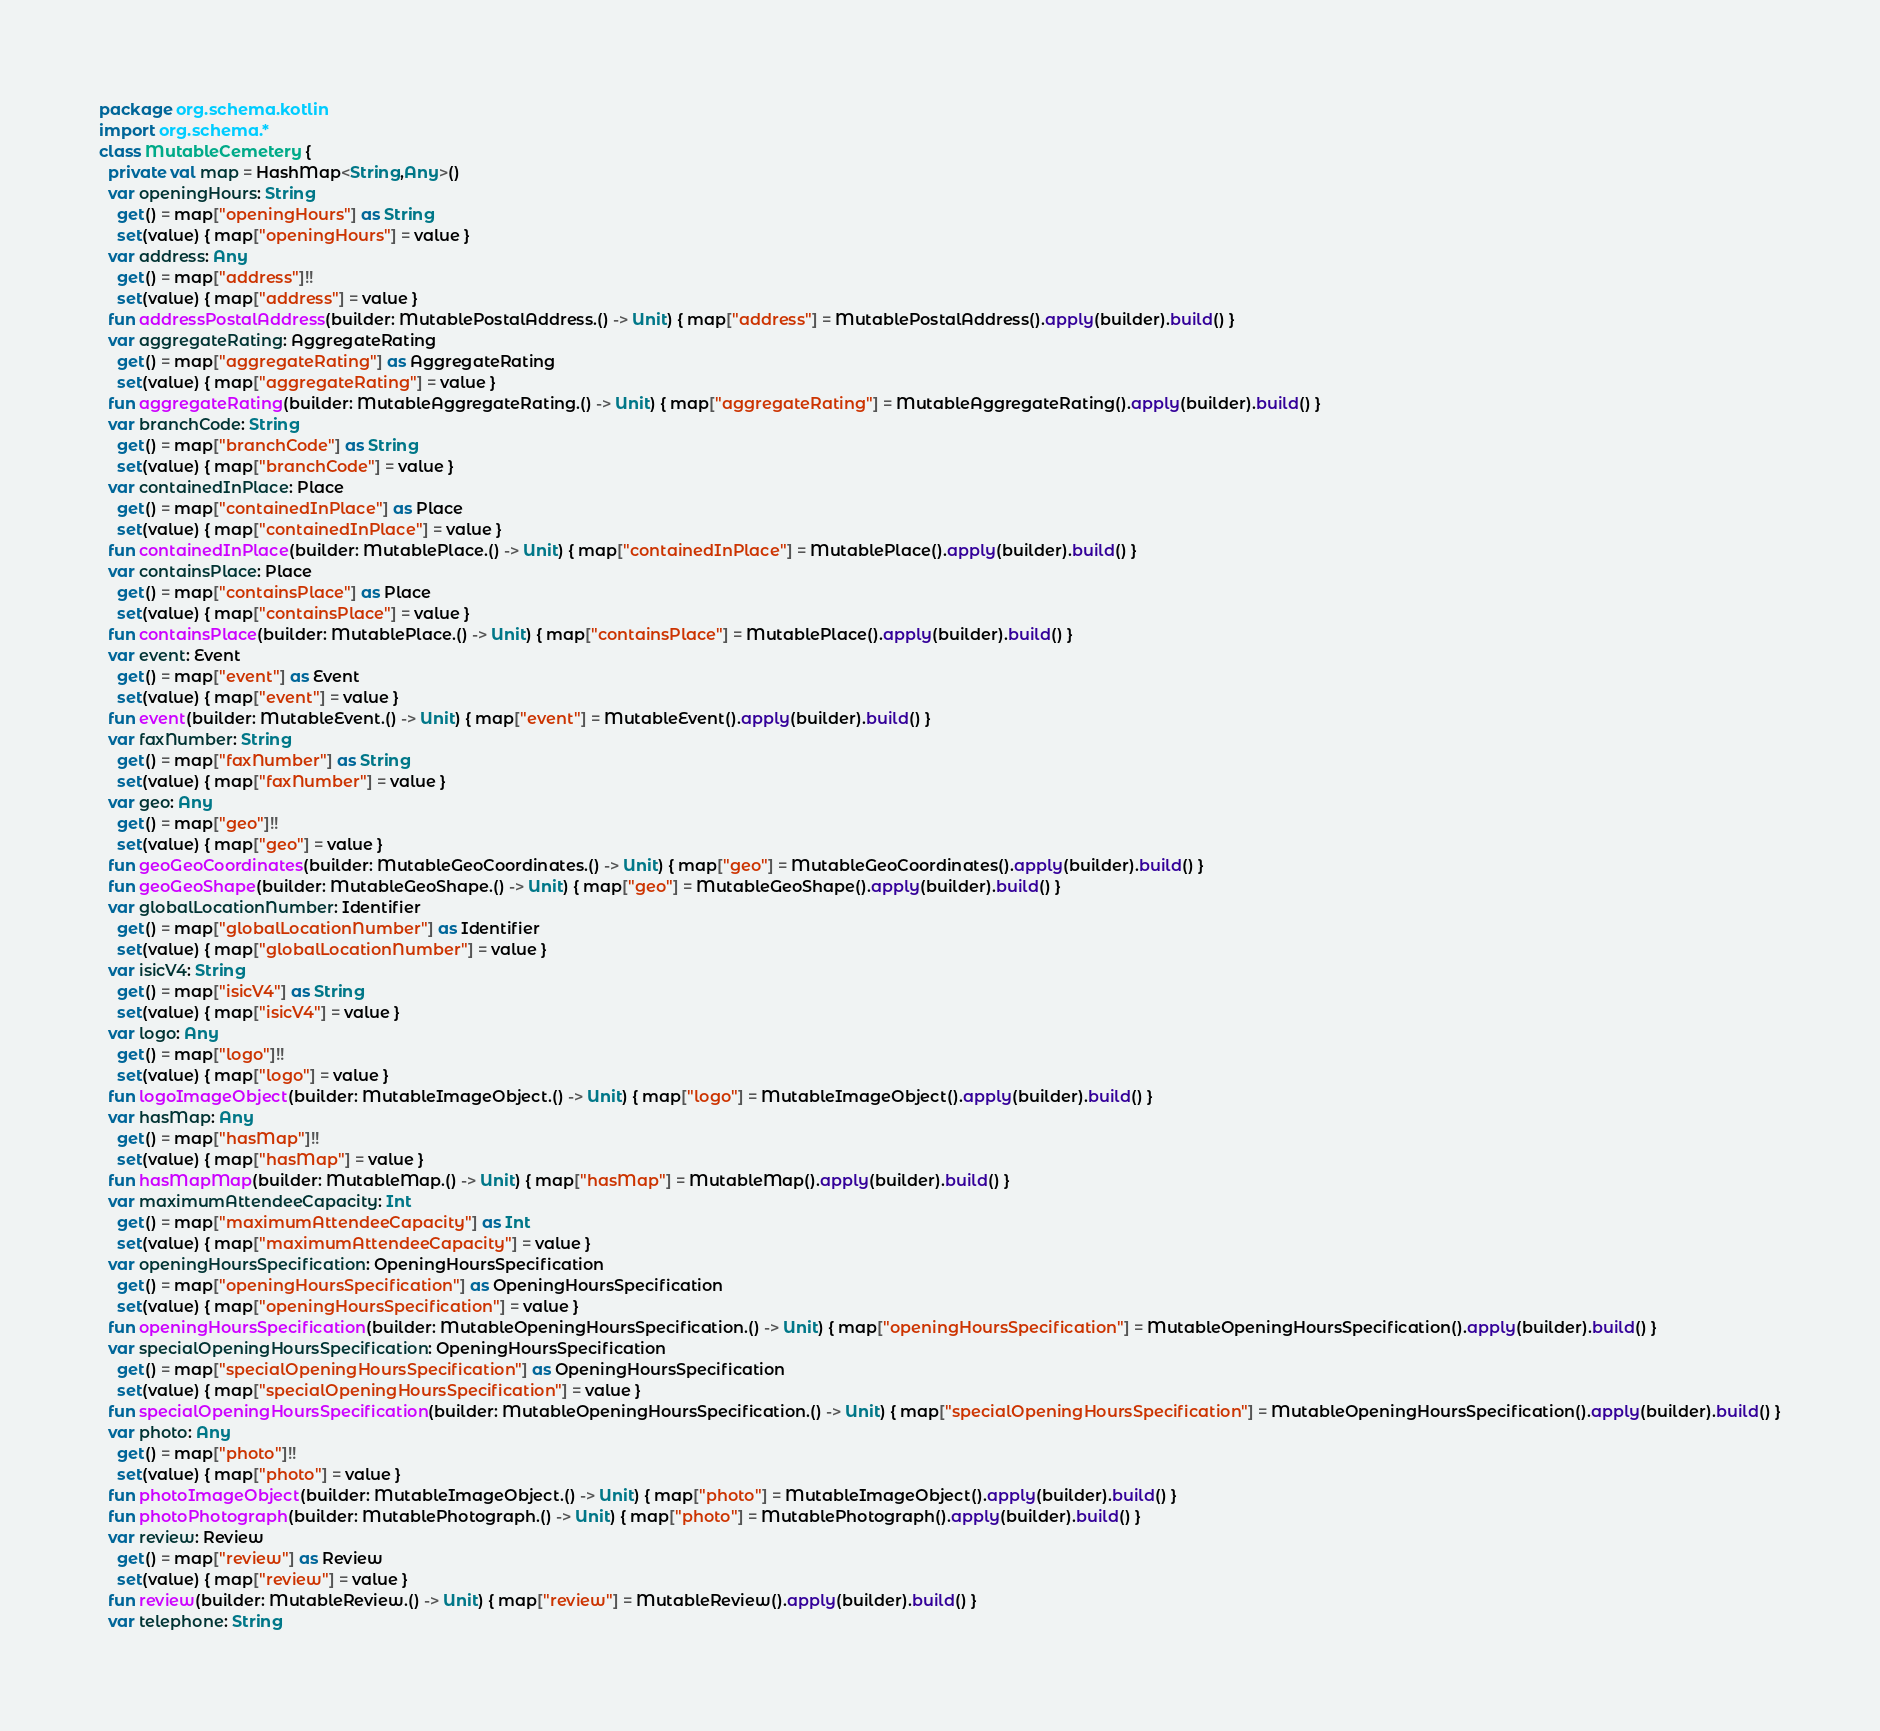Convert code to text. <code><loc_0><loc_0><loc_500><loc_500><_Kotlin_>package org.schema.kotlin
import org.schema.*
class MutableCemetery {
  private val map = HashMap<String,Any>()
  var openingHours: String
    get() = map["openingHours"] as String
    set(value) { map["openingHours"] = value }
  var address: Any
    get() = map["address"]!!
    set(value) { map["address"] = value }
  fun addressPostalAddress(builder: MutablePostalAddress.() -> Unit) { map["address"] = MutablePostalAddress().apply(builder).build() }
  var aggregateRating: AggregateRating
    get() = map["aggregateRating"] as AggregateRating
    set(value) { map["aggregateRating"] = value }
  fun aggregateRating(builder: MutableAggregateRating.() -> Unit) { map["aggregateRating"] = MutableAggregateRating().apply(builder).build() }
  var branchCode: String
    get() = map["branchCode"] as String
    set(value) { map["branchCode"] = value }
  var containedInPlace: Place
    get() = map["containedInPlace"] as Place
    set(value) { map["containedInPlace"] = value }
  fun containedInPlace(builder: MutablePlace.() -> Unit) { map["containedInPlace"] = MutablePlace().apply(builder).build() }
  var containsPlace: Place
    get() = map["containsPlace"] as Place
    set(value) { map["containsPlace"] = value }
  fun containsPlace(builder: MutablePlace.() -> Unit) { map["containsPlace"] = MutablePlace().apply(builder).build() }
  var event: Event
    get() = map["event"] as Event
    set(value) { map["event"] = value }
  fun event(builder: MutableEvent.() -> Unit) { map["event"] = MutableEvent().apply(builder).build() }
  var faxNumber: String
    get() = map["faxNumber"] as String
    set(value) { map["faxNumber"] = value }
  var geo: Any
    get() = map["geo"]!!
    set(value) { map["geo"] = value }
  fun geoGeoCoordinates(builder: MutableGeoCoordinates.() -> Unit) { map["geo"] = MutableGeoCoordinates().apply(builder).build() }
  fun geoGeoShape(builder: MutableGeoShape.() -> Unit) { map["geo"] = MutableGeoShape().apply(builder).build() }
  var globalLocationNumber: Identifier
    get() = map["globalLocationNumber"] as Identifier
    set(value) { map["globalLocationNumber"] = value }
  var isicV4: String
    get() = map["isicV4"] as String
    set(value) { map["isicV4"] = value }
  var logo: Any
    get() = map["logo"]!!
    set(value) { map["logo"] = value }
  fun logoImageObject(builder: MutableImageObject.() -> Unit) { map["logo"] = MutableImageObject().apply(builder).build() }
  var hasMap: Any
    get() = map["hasMap"]!!
    set(value) { map["hasMap"] = value }
  fun hasMapMap(builder: MutableMap.() -> Unit) { map["hasMap"] = MutableMap().apply(builder).build() }
  var maximumAttendeeCapacity: Int
    get() = map["maximumAttendeeCapacity"] as Int
    set(value) { map["maximumAttendeeCapacity"] = value }
  var openingHoursSpecification: OpeningHoursSpecification
    get() = map["openingHoursSpecification"] as OpeningHoursSpecification
    set(value) { map["openingHoursSpecification"] = value }
  fun openingHoursSpecification(builder: MutableOpeningHoursSpecification.() -> Unit) { map["openingHoursSpecification"] = MutableOpeningHoursSpecification().apply(builder).build() }
  var specialOpeningHoursSpecification: OpeningHoursSpecification
    get() = map["specialOpeningHoursSpecification"] as OpeningHoursSpecification
    set(value) { map["specialOpeningHoursSpecification"] = value }
  fun specialOpeningHoursSpecification(builder: MutableOpeningHoursSpecification.() -> Unit) { map["specialOpeningHoursSpecification"] = MutableOpeningHoursSpecification().apply(builder).build() }
  var photo: Any
    get() = map["photo"]!!
    set(value) { map["photo"] = value }
  fun photoImageObject(builder: MutableImageObject.() -> Unit) { map["photo"] = MutableImageObject().apply(builder).build() }
  fun photoPhotograph(builder: MutablePhotograph.() -> Unit) { map["photo"] = MutablePhotograph().apply(builder).build() }
  var review: Review
    get() = map["review"] as Review
    set(value) { map["review"] = value }
  fun review(builder: MutableReview.() -> Unit) { map["review"] = MutableReview().apply(builder).build() }
  var telephone: String</code> 